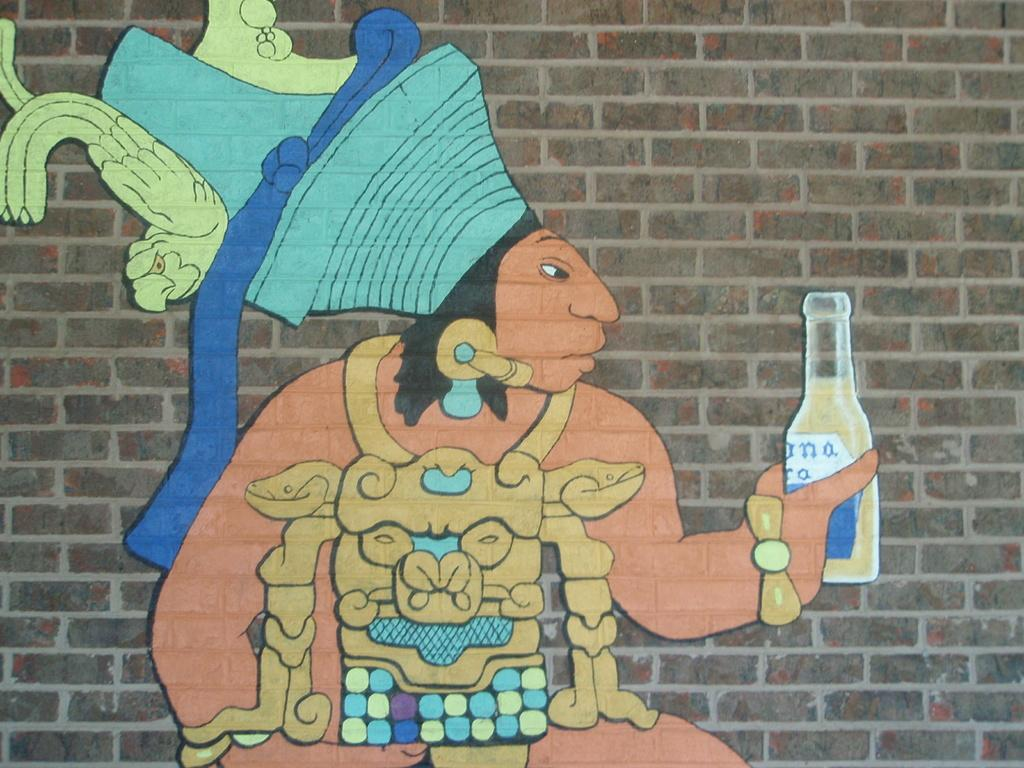<image>
Share a concise interpretation of the image provided. An Indian wearing a headdress and holding a Corona is spray painted on the side of a brick building. 